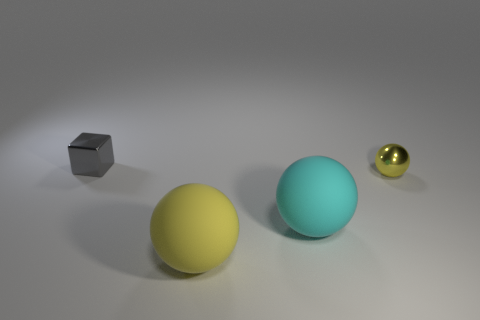Are there any other gray metallic cubes of the same size as the gray cube? Upon examining the image, I can confirm that there are no other objects that match the description of being gray metallic cubes of the same size as the one present. 